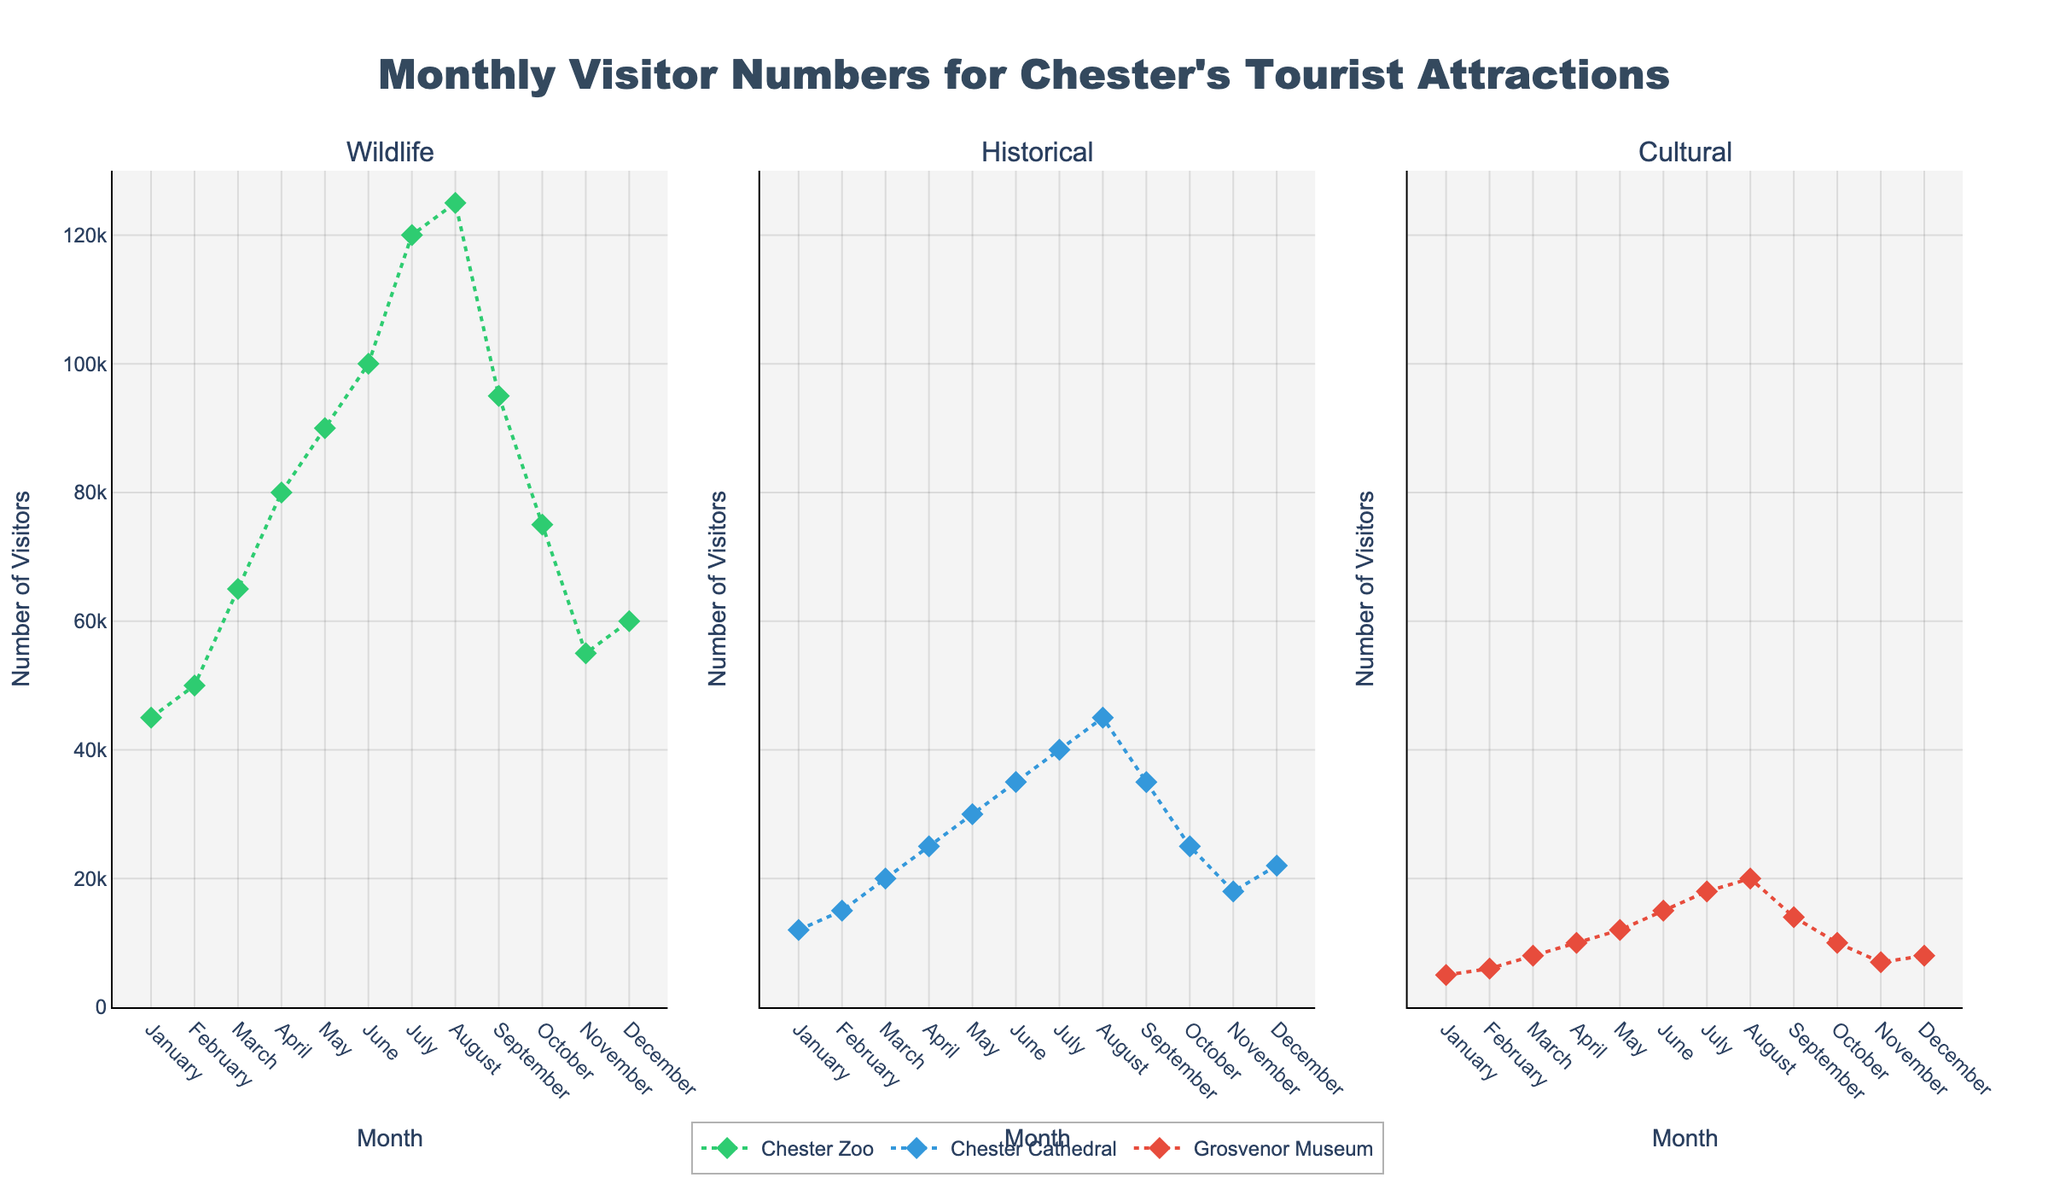What is the title of the figure? The title of a figure is usually displayed at the top center. By examining the top part of the figure, we can see the text.
Answer: Monthly Visitor Numbers for Chester's Tourist Attractions In which month did Chester Zoo have the highest number of visitors? Look at the Wildlife subplot and identify the month with the peak value on the y-axis for the Chester Zoo scatter line.
Answer: August What are the visitor numbers for Chester Cathedral in March? In the Historical subplot, find the data point for March and read the y-axis value corresponding to the Chester Cathedral scatter line.
Answer: 20,000 How much higher were the visitor numbers at Chester Zoo compared to Grosvenor Museum in July? Identify the y-values for Chester Zoo and Grosvenor Museum in July from the Wildlife and Cultural subplots respectively, then subtract the latter from the former.
Answer: 102,000 What is the average number of visitors to the Grosvenor Museum from January to March? Add the number of visitors to the Grosvenor Museum for January, February, and March from the Cultural subplot, and then divide by 3.
Answer: 6,333 Which month shows a decrease in the number of visitors to all three attractions? Compare each month for a downward trend across the Wildlife, Historical, and Cultural subplots.
Answer: September In which subplot are the months aligned horizontally and which axis lists them? Observing the layout of all three subplots, we see that months are aligned along the x-axis in all subplots.
Answer: All subplots, x-axis By what percentage did visitor numbers to Chester Cathedral increase from January to July? Take the visitor numbers for Chester Cathedral in January and July, calculate the increase, then divide by January's number and multiply by 100.
Answer: 233.33% Which attraction type has the steepest increase in visitor numbers between any two consecutive months? Look for the largest change in visitor numbers between any two consecutive months in the Wildlife, Historical, and Cultural subplots.
Answer: Wildlife (June-July) Is there any month where any attraction shows exactly 5000 visitors? Stroller through each subplot and find any data point on the y-axis corresponding to 5000 visitors.
Answer: January, Grosvenor Museum 